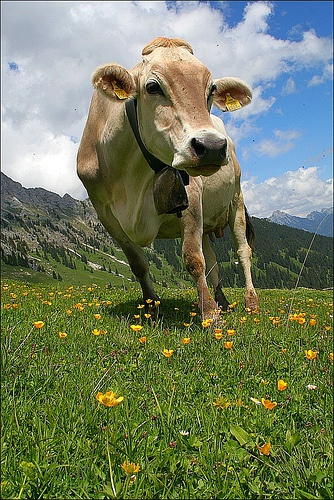Describe the objects in this image and their specific colors. I can see a cow in black, darkgreen, tan, and gray tones in this image. 